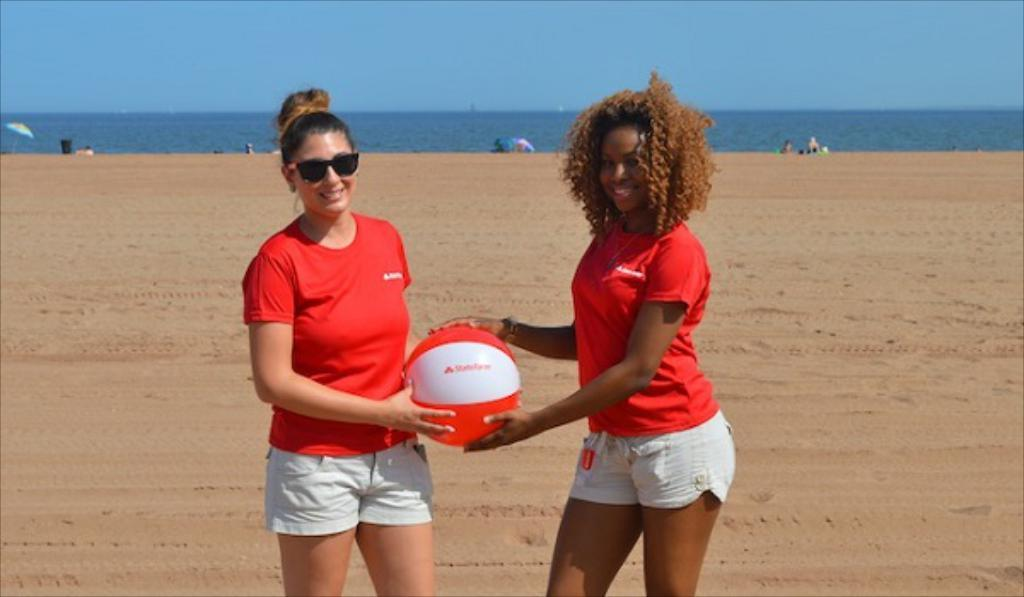How many women are in the image? There are 2 women in the image. What are the women doing in the image? Both women are standing and smiling. What are the women holding in the image? Both women are holding a ball. What can be seen in the background of the image? There is sand, water, and the sky visible in the background of the image. What type of sleet can be seen falling in the image? There is no sleet present in the image; it is not raining or snowing. How does the control panel in the image affect the women's actions? There is no control panel present in the image; the women are simply standing and holding a ball. 